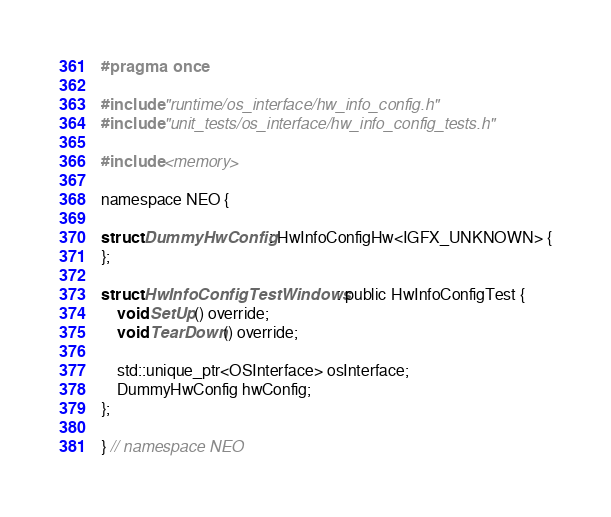<code> <loc_0><loc_0><loc_500><loc_500><_C_>
#pragma once

#include "runtime/os_interface/hw_info_config.h"
#include "unit_tests/os_interface/hw_info_config_tests.h"

#include <memory>

namespace NEO {

struct DummyHwConfig : HwInfoConfigHw<IGFX_UNKNOWN> {
};

struct HwInfoConfigTestWindows : public HwInfoConfigTest {
    void SetUp() override;
    void TearDown() override;

    std::unique_ptr<OSInterface> osInterface;
    DummyHwConfig hwConfig;
};

} // namespace NEO
</code> 